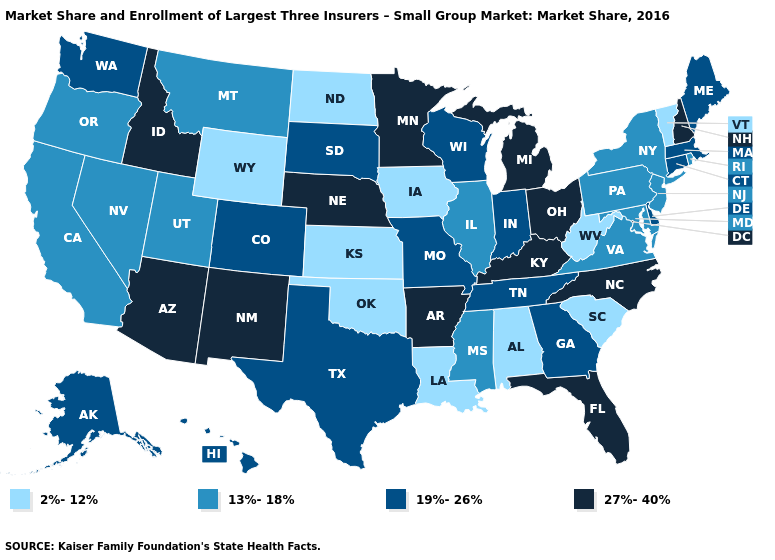What is the value of Arizona?
Write a very short answer. 27%-40%. Name the states that have a value in the range 27%-40%?
Be succinct. Arizona, Arkansas, Florida, Idaho, Kentucky, Michigan, Minnesota, Nebraska, New Hampshire, New Mexico, North Carolina, Ohio. What is the highest value in the USA?
Write a very short answer. 27%-40%. Does Iowa have a lower value than Oklahoma?
Write a very short answer. No. Name the states that have a value in the range 27%-40%?
Short answer required. Arizona, Arkansas, Florida, Idaho, Kentucky, Michigan, Minnesota, Nebraska, New Hampshire, New Mexico, North Carolina, Ohio. Does the first symbol in the legend represent the smallest category?
Write a very short answer. Yes. Name the states that have a value in the range 19%-26%?
Concise answer only. Alaska, Colorado, Connecticut, Delaware, Georgia, Hawaii, Indiana, Maine, Massachusetts, Missouri, South Dakota, Tennessee, Texas, Washington, Wisconsin. How many symbols are there in the legend?
Quick response, please. 4. Among the states that border California , which have the lowest value?
Give a very brief answer. Nevada, Oregon. Which states have the lowest value in the South?
Give a very brief answer. Alabama, Louisiana, Oklahoma, South Carolina, West Virginia. Which states have the lowest value in the MidWest?
Short answer required. Iowa, Kansas, North Dakota. Name the states that have a value in the range 27%-40%?
Answer briefly. Arizona, Arkansas, Florida, Idaho, Kentucky, Michigan, Minnesota, Nebraska, New Hampshire, New Mexico, North Carolina, Ohio. Name the states that have a value in the range 19%-26%?
Answer briefly. Alaska, Colorado, Connecticut, Delaware, Georgia, Hawaii, Indiana, Maine, Massachusetts, Missouri, South Dakota, Tennessee, Texas, Washington, Wisconsin. Does the map have missing data?
Write a very short answer. No. What is the value of Tennessee?
Write a very short answer. 19%-26%. 